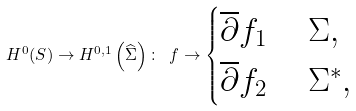<formula> <loc_0><loc_0><loc_500><loc_500>H ^ { 0 } ( S ) \to H ^ { 0 , 1 } \left ( \widehat { \Sigma } \right ) \colon \ f \to \begin{cases} \overline { \partial } f _ { 1 } & \ \Sigma , \\ \overline { \partial } f _ { 2 } & \ \Sigma ^ { * } , \end{cases}</formula> 